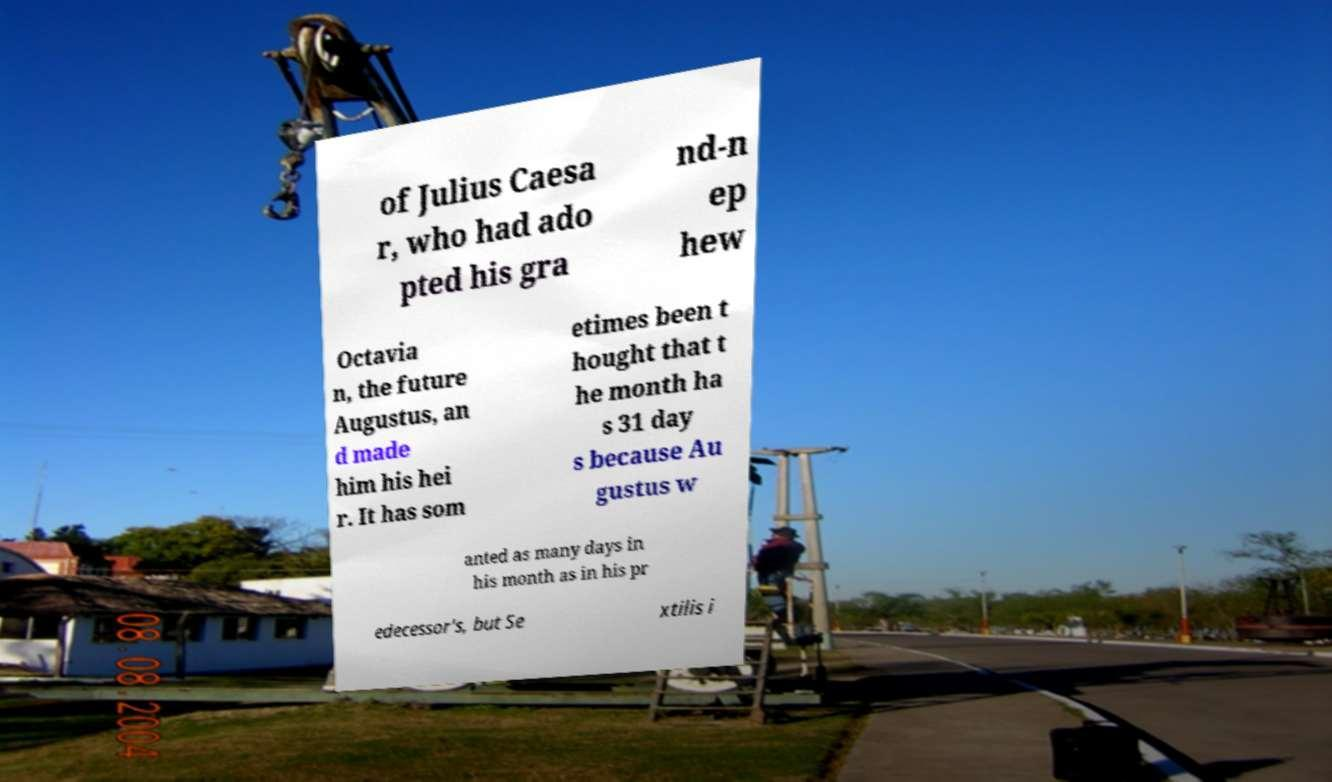Could you assist in decoding the text presented in this image and type it out clearly? of Julius Caesa r, who had ado pted his gra nd-n ep hew Octavia n, the future Augustus, an d made him his hei r. It has som etimes been t hought that t he month ha s 31 day s because Au gustus w anted as many days in his month as in his pr edecessor's, but Se xtilis i 